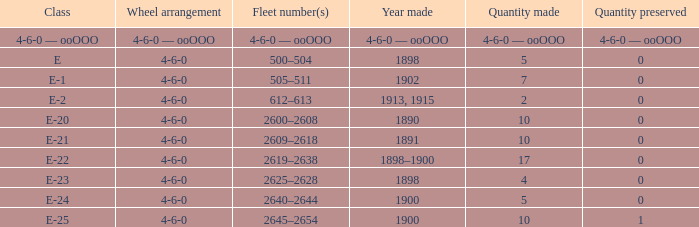What is the maintained quantity of the e-1 group? 0.0. Would you mind parsing the complete table? {'header': ['Class', 'Wheel arrangement', 'Fleet number(s)', 'Year made', 'Quantity made', 'Quantity preserved'], 'rows': [['4-6-0 — ooOOO', '4-6-0 — ooOOO', '4-6-0 — ooOOO', '4-6-0 — ooOOO', '4-6-0 — ooOOO', '4-6-0 — ooOOO'], ['E', '4-6-0', '500–504', '1898', '5', '0'], ['E-1', '4-6-0', '505–511', '1902', '7', '0'], ['E-2', '4-6-0', '612–613', '1913, 1915', '2', '0'], ['E-20', '4-6-0', '2600–2608', '1890', '10', '0'], ['E-21', '4-6-0', '2609–2618', '1891', '10', '0'], ['E-22', '4-6-0', '2619–2638', '1898–1900', '17', '0'], ['E-23', '4-6-0', '2625–2628', '1898', '4', '0'], ['E-24', '4-6-0', '2640–2644', '1900', '5', '0'], ['E-25', '4-6-0', '2645–2654', '1900', '10', '1']]} 